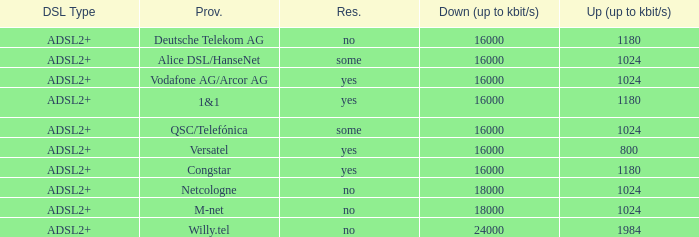Could you parse the entire table as a dict? {'header': ['DSL Type', 'Prov.', 'Res.', 'Down (up to kbit/s)', 'Up (up to kbit/s)'], 'rows': [['ADSL2+', 'Deutsche Telekom AG', 'no', '16000', '1180'], ['ADSL2+', 'Alice DSL/HanseNet', 'some', '16000', '1024'], ['ADSL2+', 'Vodafone AG/Arcor AG', 'yes', '16000', '1024'], ['ADSL2+', '1&1', 'yes', '16000', '1180'], ['ADSL2+', 'QSC/Telefónica', 'some', '16000', '1024'], ['ADSL2+', 'Versatel', 'yes', '16000', '800'], ['ADSL2+', 'Congstar', 'yes', '16000', '1180'], ['ADSL2+', 'Netcologne', 'no', '18000', '1024'], ['ADSL2+', 'M-net', 'no', '18000', '1024'], ['ADSL2+', 'Willy.tel', 'no', '24000', '1984']]} How many providers are there where the resale category is yes and bandwith is up is 1024? 1.0. 